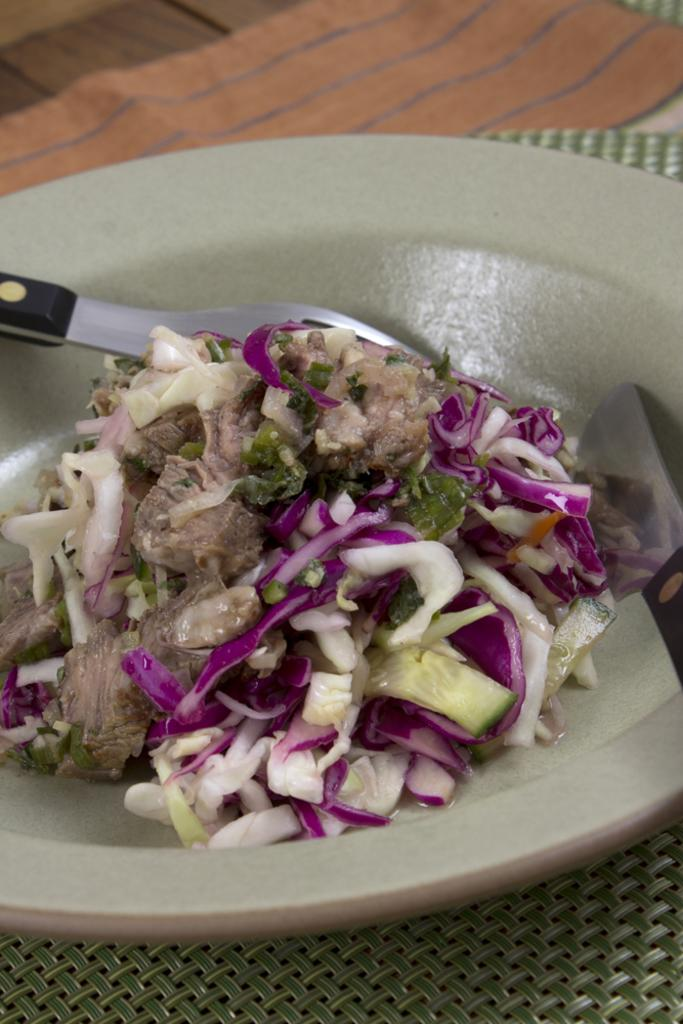What is on the plate that is visible in the image? There is a salad on the plate. What type of food is in the salad? The salad contains pieces of vegetables. What is the plate placed on in the image? The plate is on a mat. What utensils are present in the image? There is a fork and a knife in the image. What type of hair is visible in the image? There is no hair present in the image; it features a plate with a salad and utensils. 